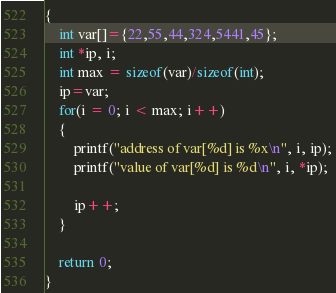<code> <loc_0><loc_0><loc_500><loc_500><_C_>{
    int var[]={22,55,44,324,5441,45};
    int *ip, i;
    int max = sizeof(var)/sizeof(int);
    ip=var;
    for(i = 0; i < max; i++)
    {
        printf("address of var[%d] is %x\n", i, ip);
        printf("value of var[%d] is %d\n", i, *ip);

        ip++;
    }

    return 0;
}
</code> 